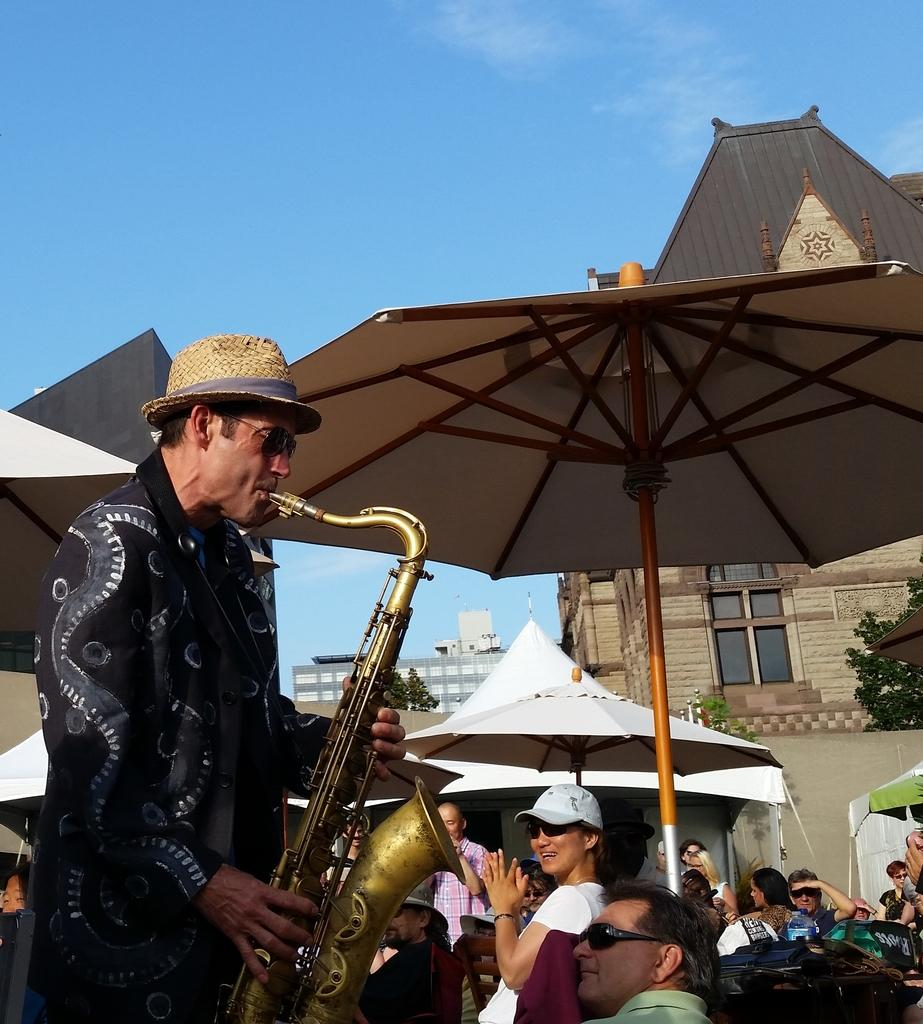What is happening in the image involving a group of people? There is a group of people in the image, and one person is playing a musical instrument. Can you describe the person playing the musical instrument? The person playing the musical instrument is wearing a hat. What can be seen in the background of the image? There are buildings and the sky visible in the background of the image. What type of reaction can be seen from the crook in the image? There is no crook present in the image; it features a group of people with one person playing a musical instrument. How does the water appear in the image, with waves or without waves? There is no water visible in the image; it features a group of people, a person playing a musical instrument, buildings, and the sky in the background. 